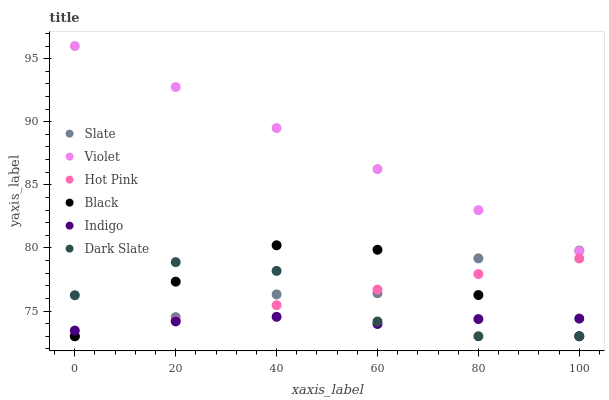Does Indigo have the minimum area under the curve?
Answer yes or no. Yes. Does Violet have the maximum area under the curve?
Answer yes or no. Yes. Does Slate have the minimum area under the curve?
Answer yes or no. No. Does Slate have the maximum area under the curve?
Answer yes or no. No. Is Violet the smoothest?
Answer yes or no. Yes. Is Dark Slate the roughest?
Answer yes or no. Yes. Is Slate the smoothest?
Answer yes or no. No. Is Slate the roughest?
Answer yes or no. No. Does Slate have the lowest value?
Answer yes or no. Yes. Does Violet have the lowest value?
Answer yes or no. No. Does Violet have the highest value?
Answer yes or no. Yes. Does Slate have the highest value?
Answer yes or no. No. Is Indigo less than Violet?
Answer yes or no. Yes. Is Violet greater than Hot Pink?
Answer yes or no. Yes. Does Hot Pink intersect Black?
Answer yes or no. Yes. Is Hot Pink less than Black?
Answer yes or no. No. Is Hot Pink greater than Black?
Answer yes or no. No. Does Indigo intersect Violet?
Answer yes or no. No. 